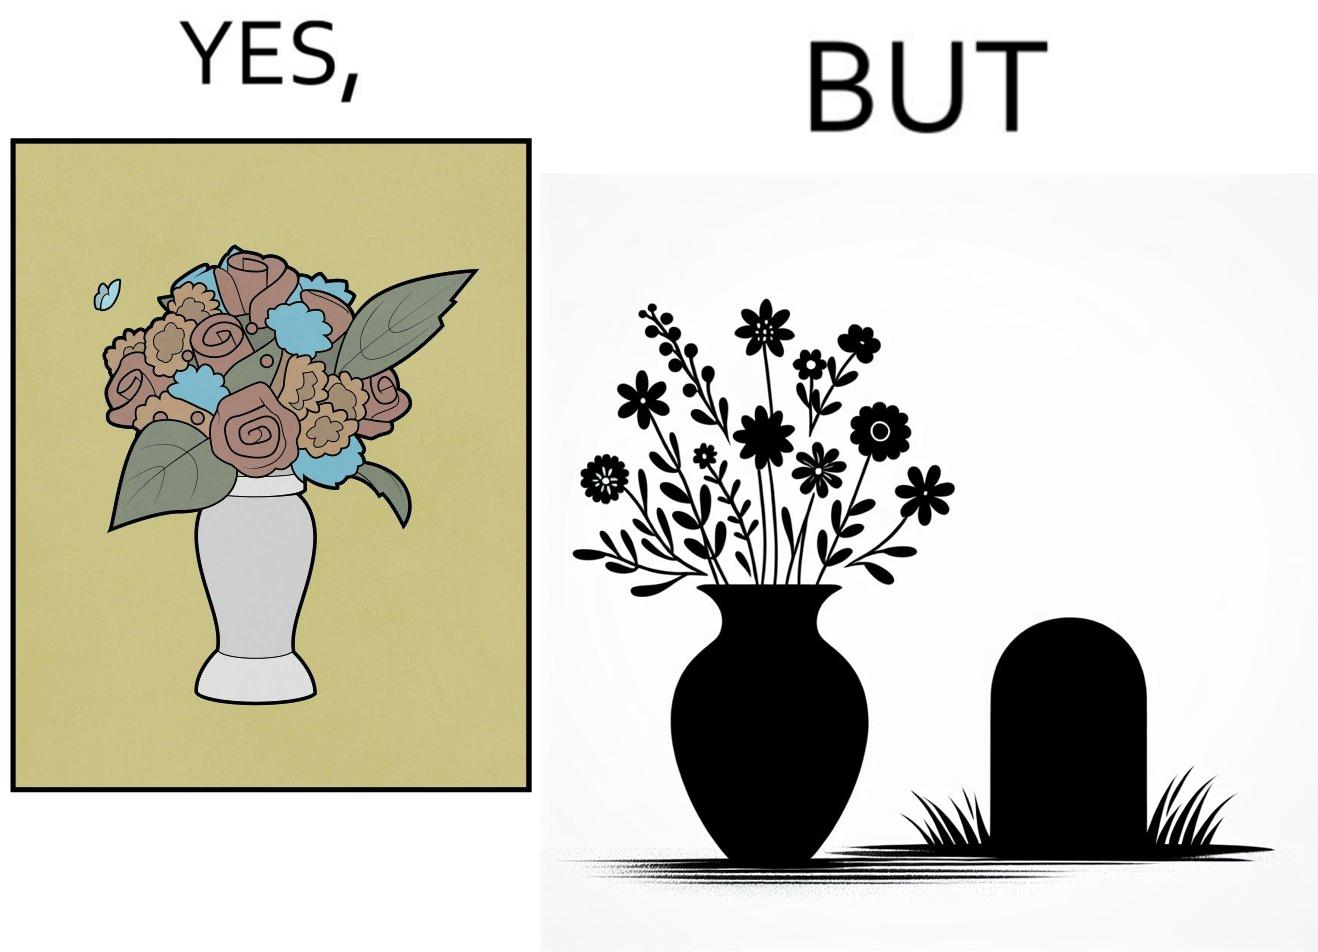Would you classify this image as satirical? Yes, this image is satirical. 